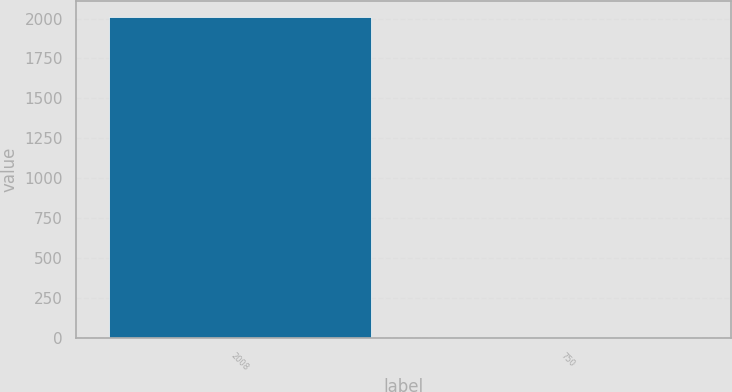Convert chart to OTSL. <chart><loc_0><loc_0><loc_500><loc_500><bar_chart><fcel>2008<fcel>750<nl><fcel>2007<fcel>6.5<nl></chart> 